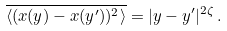<formula> <loc_0><loc_0><loc_500><loc_500>\overline { \langle ( x ( y ) - x ( y ^ { \prime } ) ) ^ { 2 } \rangle } = | y - y ^ { \prime } | ^ { 2 \zeta } \, .</formula> 